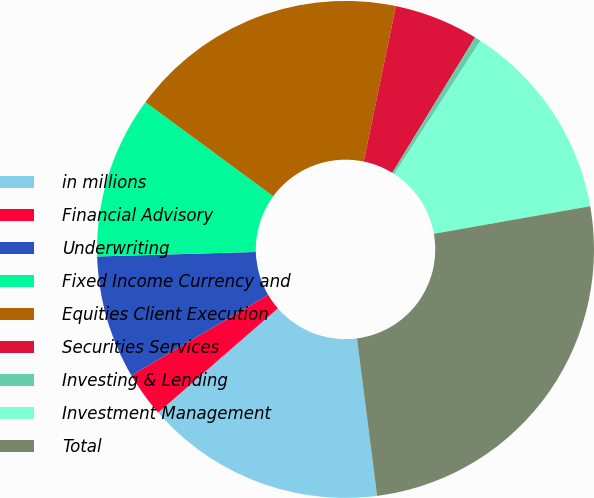Convert chart to OTSL. <chart><loc_0><loc_0><loc_500><loc_500><pie_chart><fcel>in millions<fcel>Financial Advisory<fcel>Underwriting<fcel>Fixed Income Currency and<fcel>Equities Client Execution<fcel>Securities Services<fcel>Investing & Lending<fcel>Investment Management<fcel>Total<nl><fcel>15.62%<fcel>2.94%<fcel>8.01%<fcel>10.55%<fcel>18.15%<fcel>5.48%<fcel>0.41%<fcel>13.08%<fcel>25.75%<nl></chart> 